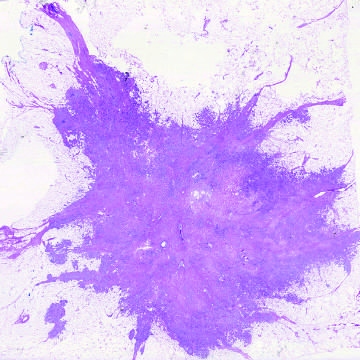what does microscopic view of breast carcinoma illustrate?
Answer the question using a single word or phrase. The invasion of breast stroma and fat by nests and cords of tumor cells 